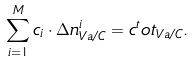<formula> <loc_0><loc_0><loc_500><loc_500>\sum _ { i = 1 } ^ { M } c _ { i } \cdot \Delta n ^ { i } _ { V a / C } = c ^ { t } o t _ { V a / C } .</formula> 